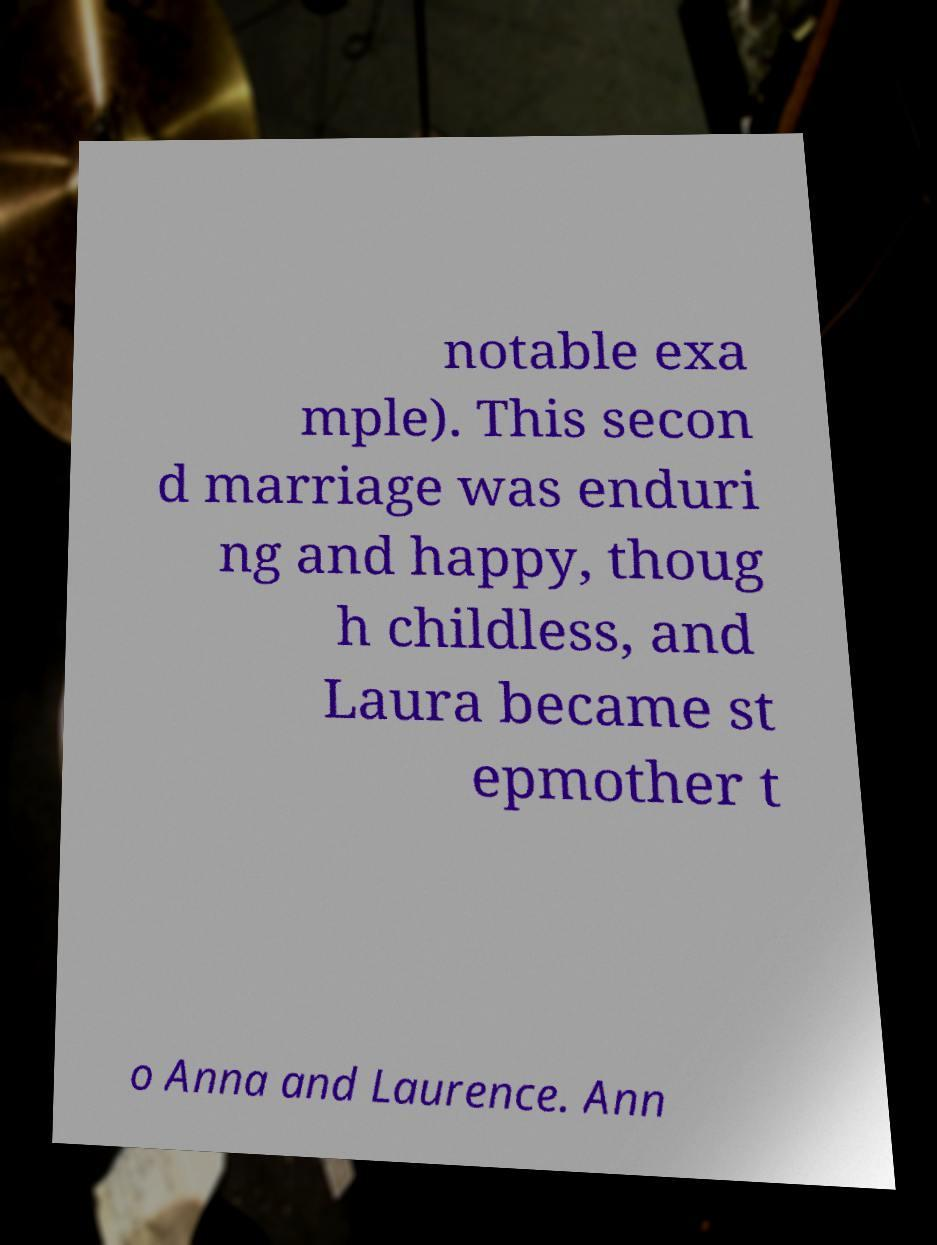Could you assist in decoding the text presented in this image and type it out clearly? notable exa mple). This secon d marriage was enduri ng and happy, thoug h childless, and Laura became st epmother t o Anna and Laurence. Ann 